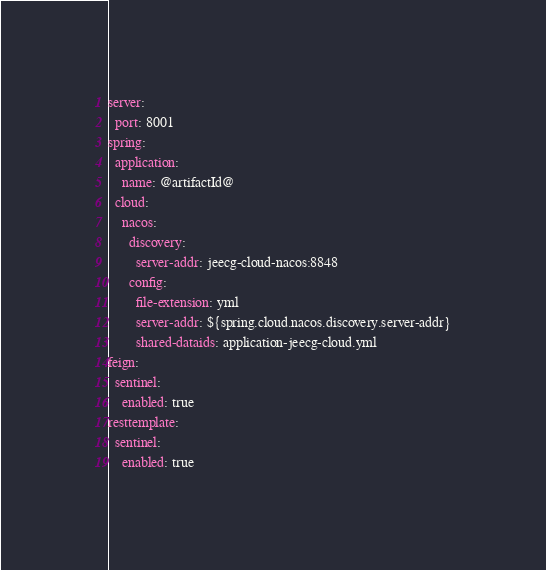Convert code to text. <code><loc_0><loc_0><loc_500><loc_500><_YAML_>server:
  port: 8001
spring:
  application:
    name: @artifactId@
  cloud:
    nacos:
      discovery:
        server-addr: jeecg-cloud-nacos:8848
      config:
        file-extension: yml
        server-addr: ${spring.cloud.nacos.discovery.server-addr}
        shared-dataids: application-jeecg-cloud.yml
feign:
  sentinel:
    enabled: true
resttemplate:
  sentinel:
    enabled: true
</code> 